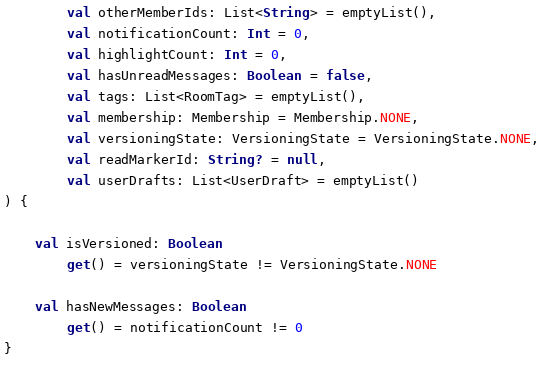Convert code to text. <code><loc_0><loc_0><loc_500><loc_500><_Kotlin_>        val otherMemberIds: List<String> = emptyList(),
        val notificationCount: Int = 0,
        val highlightCount: Int = 0,
        val hasUnreadMessages: Boolean = false,
        val tags: List<RoomTag> = emptyList(),
        val membership: Membership = Membership.NONE,
        val versioningState: VersioningState = VersioningState.NONE,
        val readMarkerId: String? = null,
        val userDrafts: List<UserDraft> = emptyList()
) {

    val isVersioned: Boolean
        get() = versioningState != VersioningState.NONE

    val hasNewMessages: Boolean
        get() = notificationCount != 0
}

</code> 